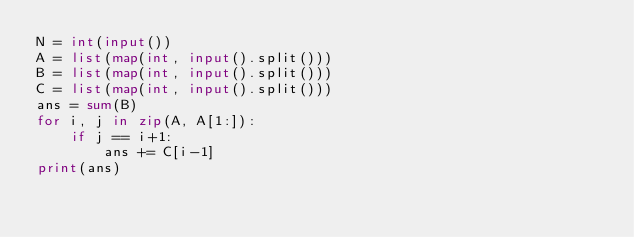Convert code to text. <code><loc_0><loc_0><loc_500><loc_500><_Python_>N = int(input())
A = list(map(int, input().split()))
B = list(map(int, input().split()))
C = list(map(int, input().split()))
ans = sum(B)
for i, j in zip(A, A[1:]):
    if j == i+1:
        ans += C[i-1]
print(ans)</code> 